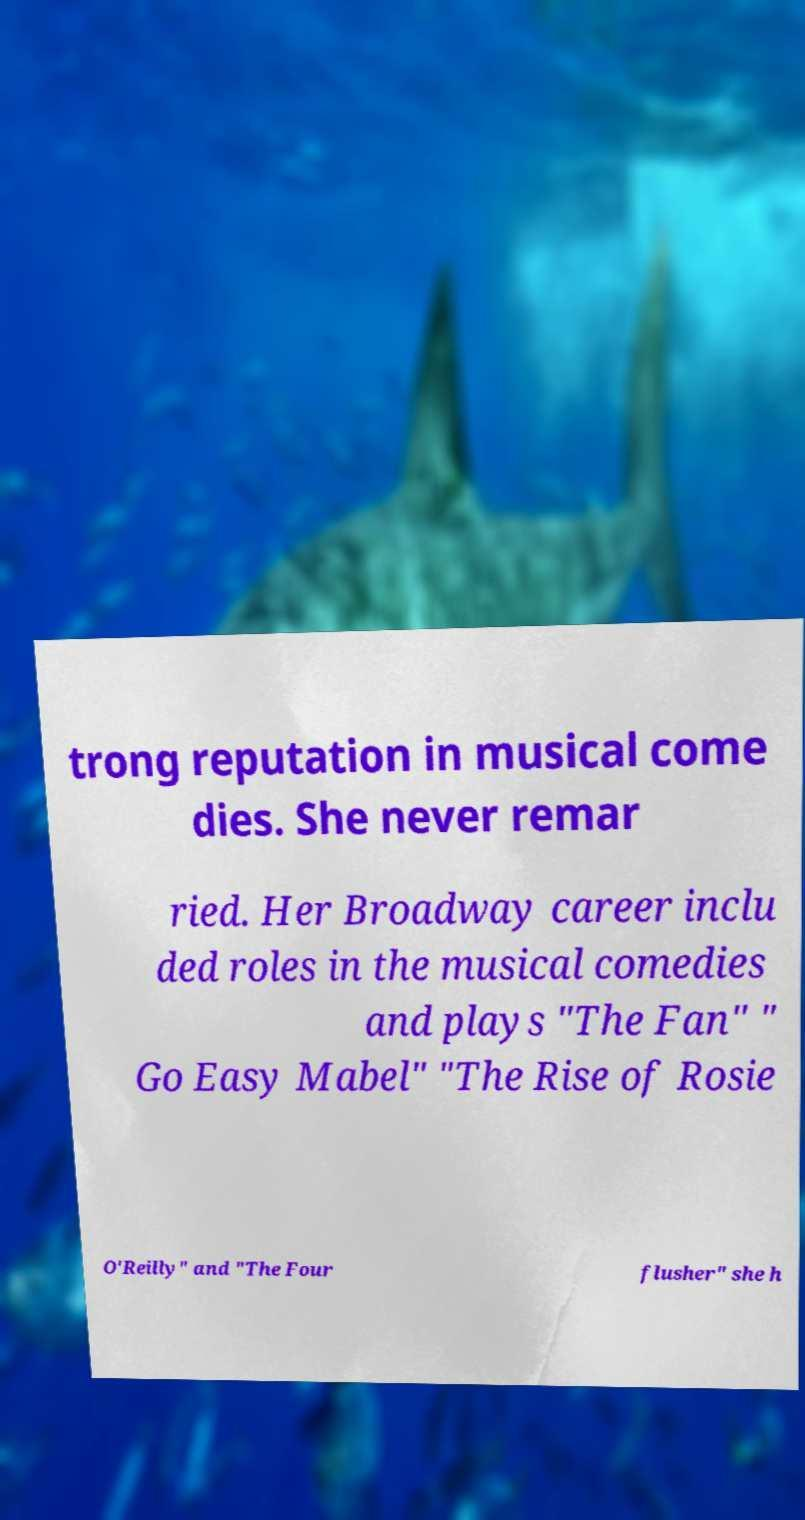I need the written content from this picture converted into text. Can you do that? trong reputation in musical come dies. She never remar ried. Her Broadway career inclu ded roles in the musical comedies and plays "The Fan" " Go Easy Mabel" "The Rise of Rosie O'Reilly" and "The Four flusher" she h 